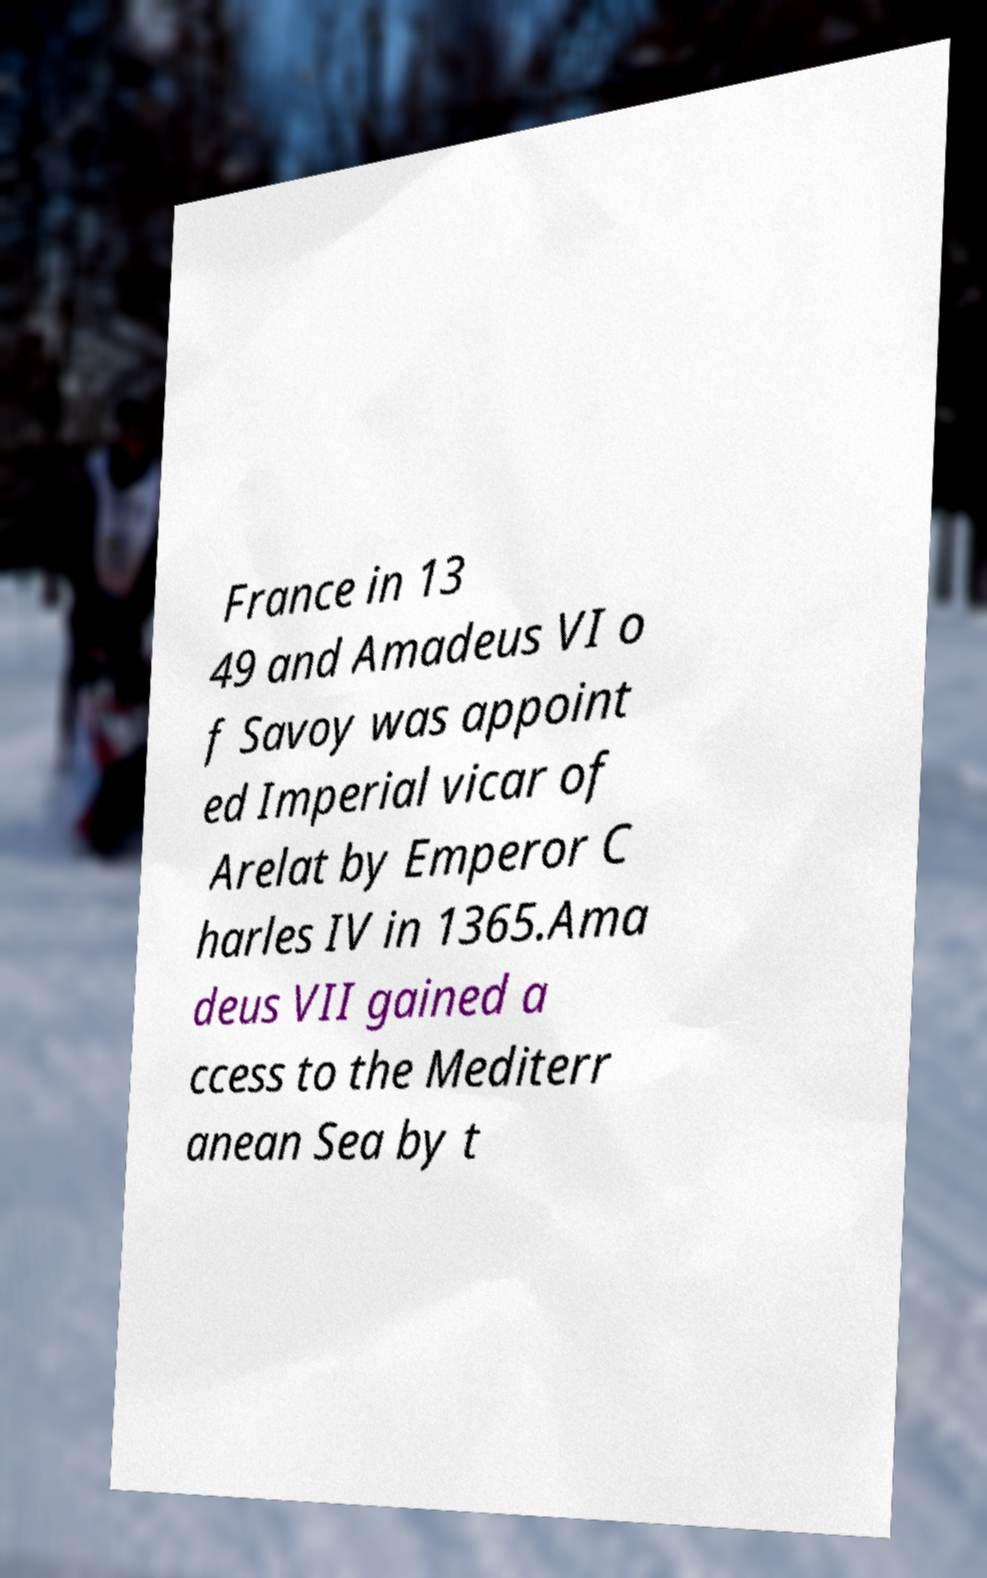Can you accurately transcribe the text from the provided image for me? France in 13 49 and Amadeus VI o f Savoy was appoint ed Imperial vicar of Arelat by Emperor C harles IV in 1365.Ama deus VII gained a ccess to the Mediterr anean Sea by t 